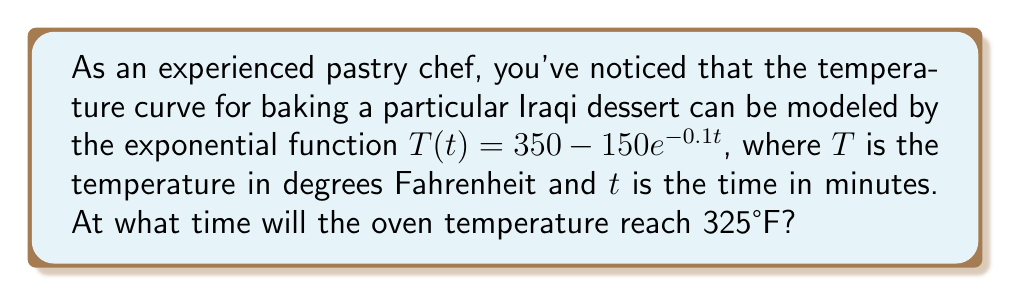Solve this math problem. To solve this problem, we need to follow these steps:

1) We are given the exponential function $T(t) = 350 - 150e^{-0.1t}$

2) We want to find $t$ when $T(t) = 325$. So, let's set up the equation:

   $325 = 350 - 150e^{-0.1t}$

3) Subtract 350 from both sides:

   $-25 = -150e^{-0.1t}$

4) Divide both sides by -150:

   $\frac{1}{6} = e^{-0.1t}$

5) Take the natural logarithm of both sides:

   $\ln(\frac{1}{6}) = \ln(e^{-0.1t})$

6) Simplify the right side using the properties of logarithms:

   $\ln(\frac{1}{6}) = -0.1t$

7) Divide both sides by -0.1:

   $\frac{\ln(\frac{1}{6})}{-0.1} = t$

8) Calculate the value (you can use a calculator for this):

   $t \approx 17.9175$ minutes

Therefore, the oven temperature will reach 325°F after approximately 17.92 minutes.
Answer: $17.92$ minutes 